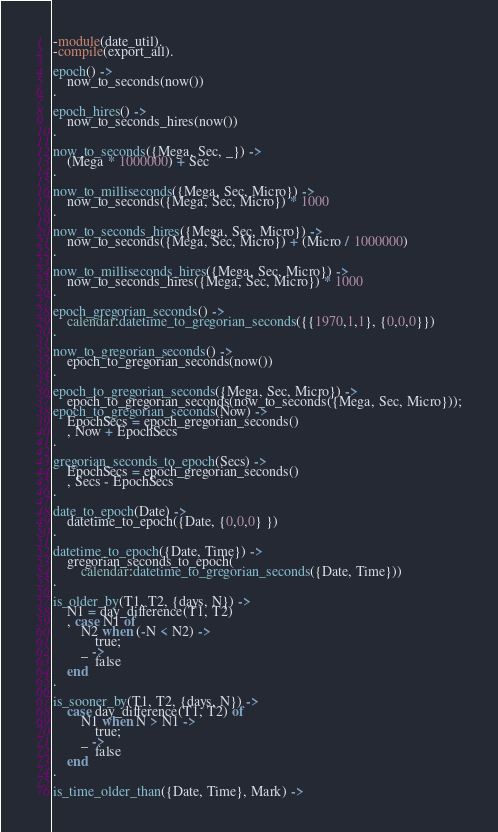Convert code to text. <code><loc_0><loc_0><loc_500><loc_500><_Erlang_>-module(date_util).
-compile(export_all).

epoch() ->
    now_to_seconds(now())
.   
    
epoch_hires() ->
    now_to_seconds_hires(now())
.   
    
now_to_seconds({Mega, Sec, _}) ->
    (Mega * 1000000) + Sec
.   
    
now_to_milliseconds({Mega, Sec, Micro}) ->
    now_to_seconds({Mega, Sec, Micro}) * 1000
.   
    
now_to_seconds_hires({Mega, Sec, Micro}) ->
    now_to_seconds({Mega, Sec, Micro}) + (Micro / 1000000)
.   
    
now_to_milliseconds_hires({Mega, Sec, Micro}) ->
    now_to_seconds_hires({Mega, Sec, Micro}) * 1000
.   
    
epoch_gregorian_seconds() ->
    calendar:datetime_to_gregorian_seconds({{1970,1,1}, {0,0,0}})
.       
        
now_to_gregorian_seconds() ->
    epoch_to_gregorian_seconds(now())
.       
        
epoch_to_gregorian_seconds({Mega, Sec, Micro}) ->
    epoch_to_gregorian_seconds(now_to_seconds({Mega, Sec, Micro}));
epoch_to_gregorian_seconds(Now) ->
    EpochSecs = epoch_gregorian_seconds()
    , Now + EpochSecs
.       

gregorian_seconds_to_epoch(Secs) ->
    EpochSecs = epoch_gregorian_seconds()
    , Secs - EpochSecs
.

date_to_epoch(Date) ->
    datetime_to_epoch({Date, {0,0,0} })
.

datetime_to_epoch({Date, Time}) ->
    gregorian_seconds_to_epoch(
        calendar:datetime_to_gregorian_seconds({Date, Time}))
.

is_older_by(T1, T2, {days, N}) ->
    N1 = day_difference(T1, T2)
    , case N1 of
        N2 when (-N < N2) ->
            true;
        _ ->
            false
    end
.

is_sooner_by(T1, T2, {days, N}) ->
    case day_difference(T1, T2) of
        N1 when N > N1 ->
            true;
        _ ->
            false
    end
.

is_time_older_than({Date, Time}, Mark) -></code> 